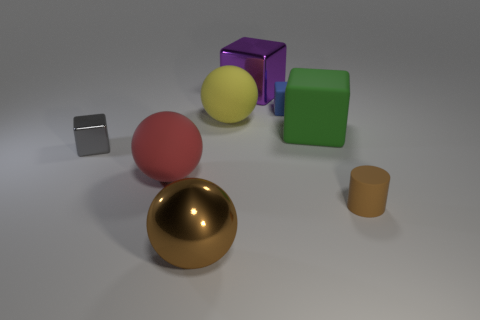Subtract 1 blocks. How many blocks are left? 3 Subtract all red blocks. Subtract all cyan cylinders. How many blocks are left? 4 Add 1 tiny purple matte objects. How many objects exist? 9 Subtract all spheres. How many objects are left? 5 Add 8 yellow metal balls. How many yellow metal balls exist? 8 Subtract 0 red cubes. How many objects are left? 8 Subtract all brown shiny blocks. Subtract all tiny blue rubber objects. How many objects are left? 7 Add 7 big matte balls. How many big matte balls are left? 9 